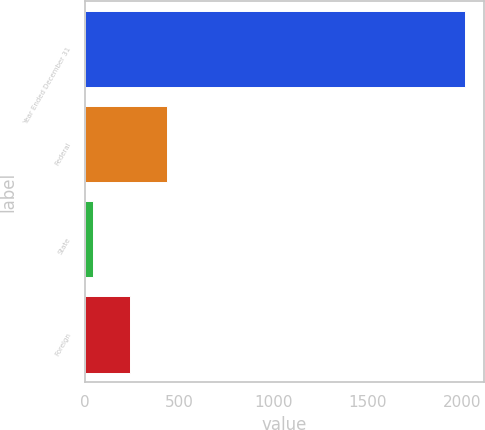<chart> <loc_0><loc_0><loc_500><loc_500><bar_chart><fcel>Year Ended December 31<fcel>Federal<fcel>State<fcel>Foreign<nl><fcel>2016<fcel>436.56<fcel>41.7<fcel>239.13<nl></chart> 